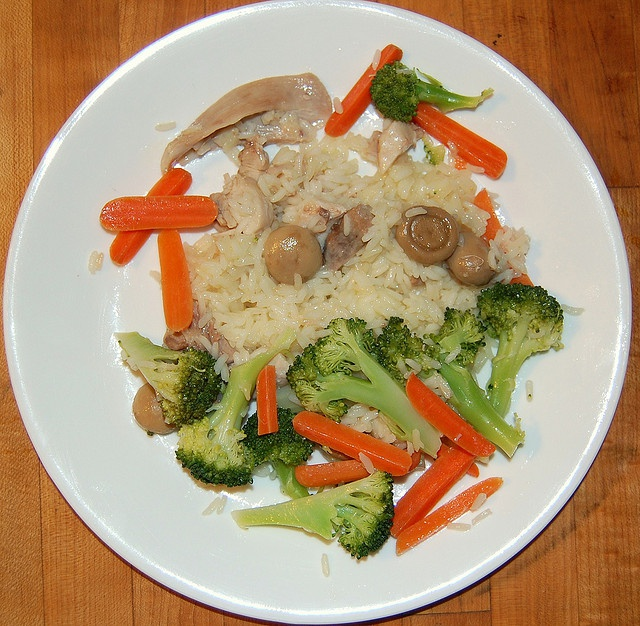Describe the objects in this image and their specific colors. I can see dining table in lightgray, brown, tan, olive, and red tones, broccoli in orange, olive, and black tones, broccoli in orange and olive tones, broccoli in orange, olive, and black tones, and broccoli in orange, olive, and black tones in this image. 